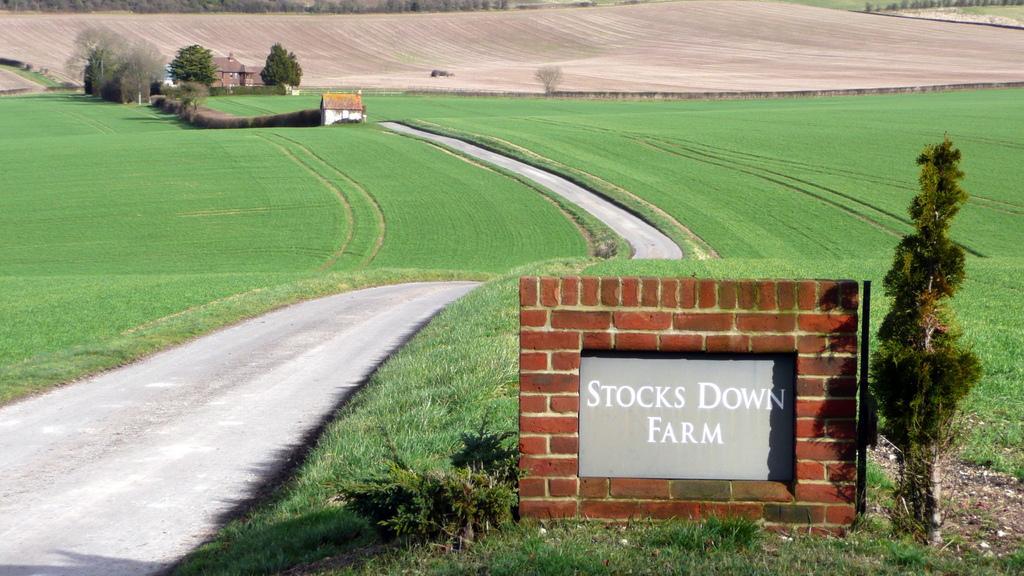In one or two sentences, can you explain what this image depicts? At bottom we can see the brick wall and stone. Beside that we can see road. In the center we can see farmland. In the bottom right corner we can see the grass. At the top left we can see building, house, trees and plants. 